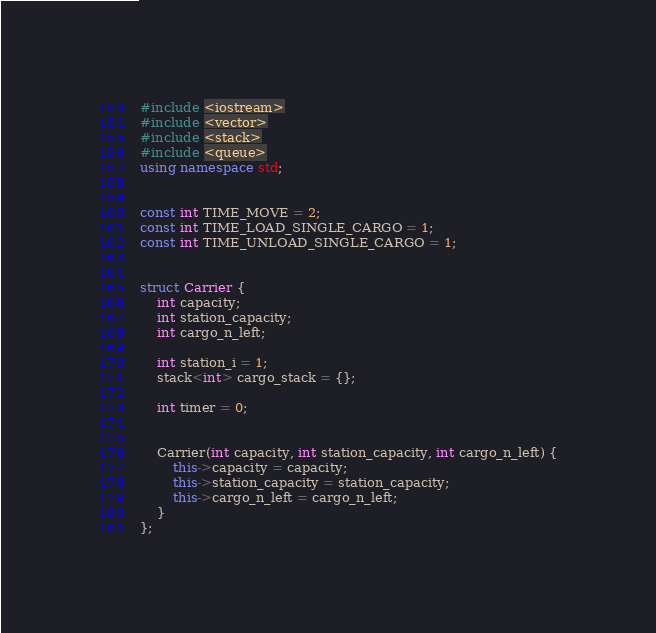<code> <loc_0><loc_0><loc_500><loc_500><_C++_>#include <iostream>
#include <vector>
#include <stack>
#include <queue>
using namespace std;


const int TIME_MOVE = 2;
const int TIME_LOAD_SINGLE_CARGO = 1;
const int TIME_UNLOAD_SINGLE_CARGO = 1;


struct Carrier {
    int capacity;
    int station_capacity;
    int cargo_n_left;

    int station_i = 1;
    stack<int> cargo_stack = {};

    int timer = 0;


    Carrier(int capacity, int station_capacity, int cargo_n_left) {
        this->capacity = capacity;
        this->station_capacity = station_capacity;
        this->cargo_n_left = cargo_n_left;
    }
};

</code> 